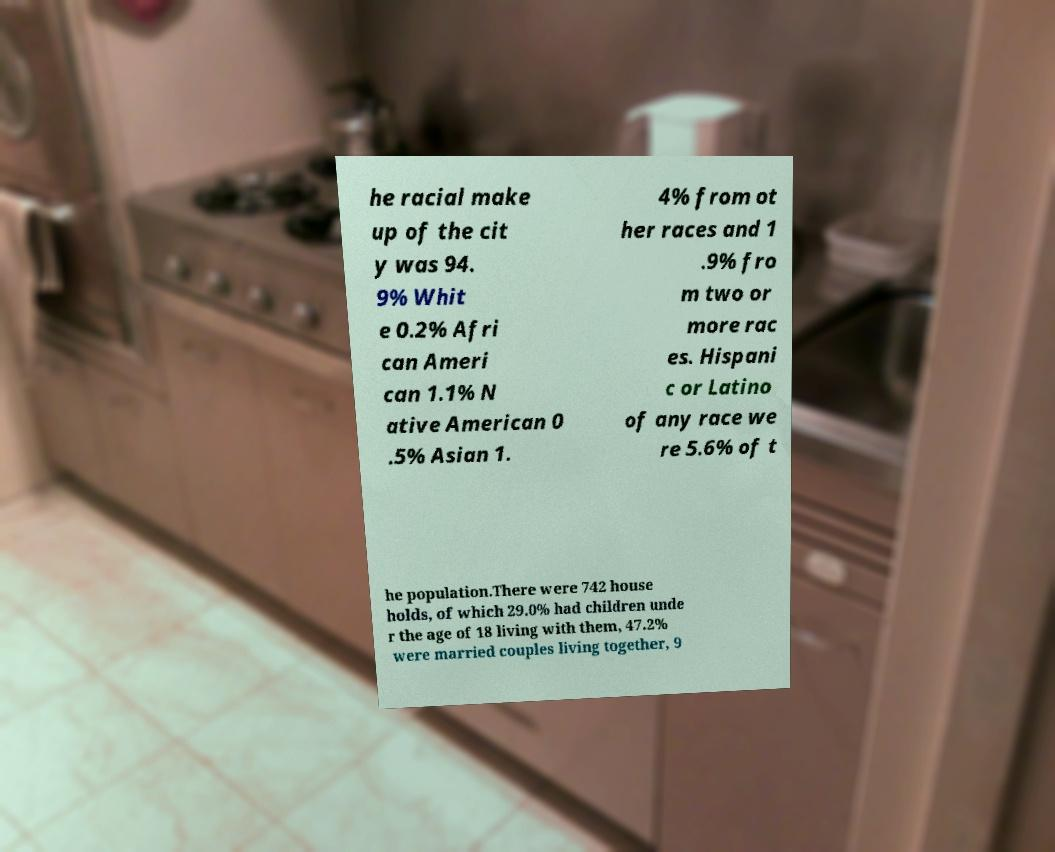Can you read and provide the text displayed in the image?This photo seems to have some interesting text. Can you extract and type it out for me? he racial make up of the cit y was 94. 9% Whit e 0.2% Afri can Ameri can 1.1% N ative American 0 .5% Asian 1. 4% from ot her races and 1 .9% fro m two or more rac es. Hispani c or Latino of any race we re 5.6% of t he population.There were 742 house holds, of which 29.0% had children unde r the age of 18 living with them, 47.2% were married couples living together, 9 